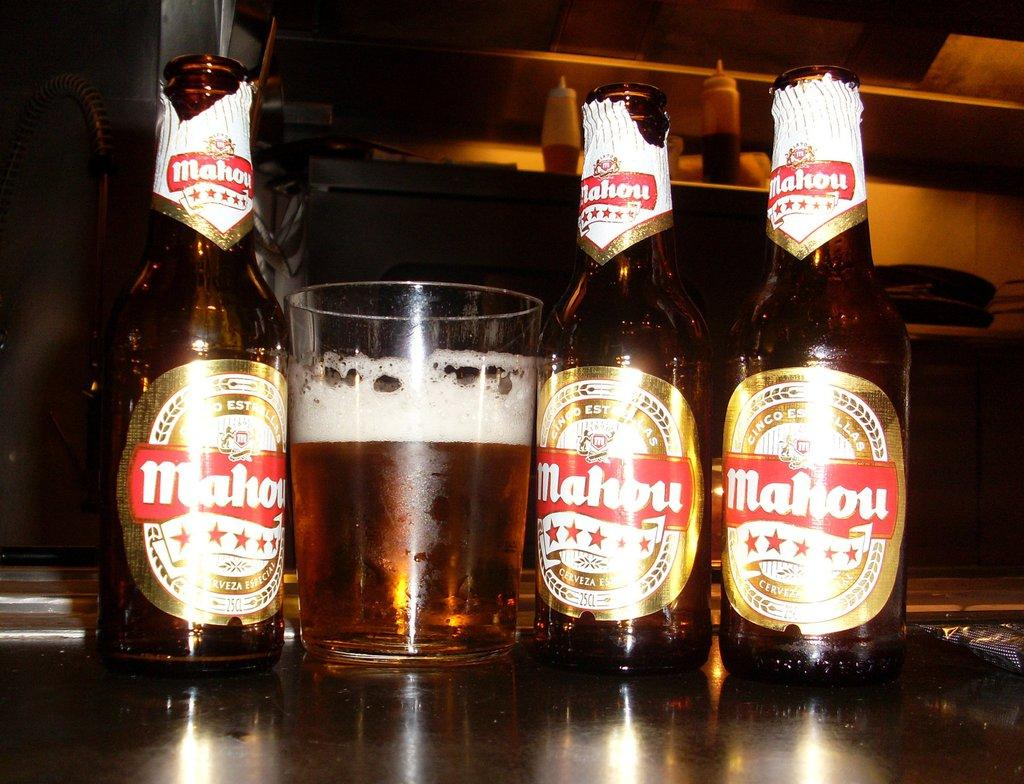<image>
Offer a succinct explanation of the picture presented. Three Mahou beer bottles and one glass likely filled with mahou beer as well. 